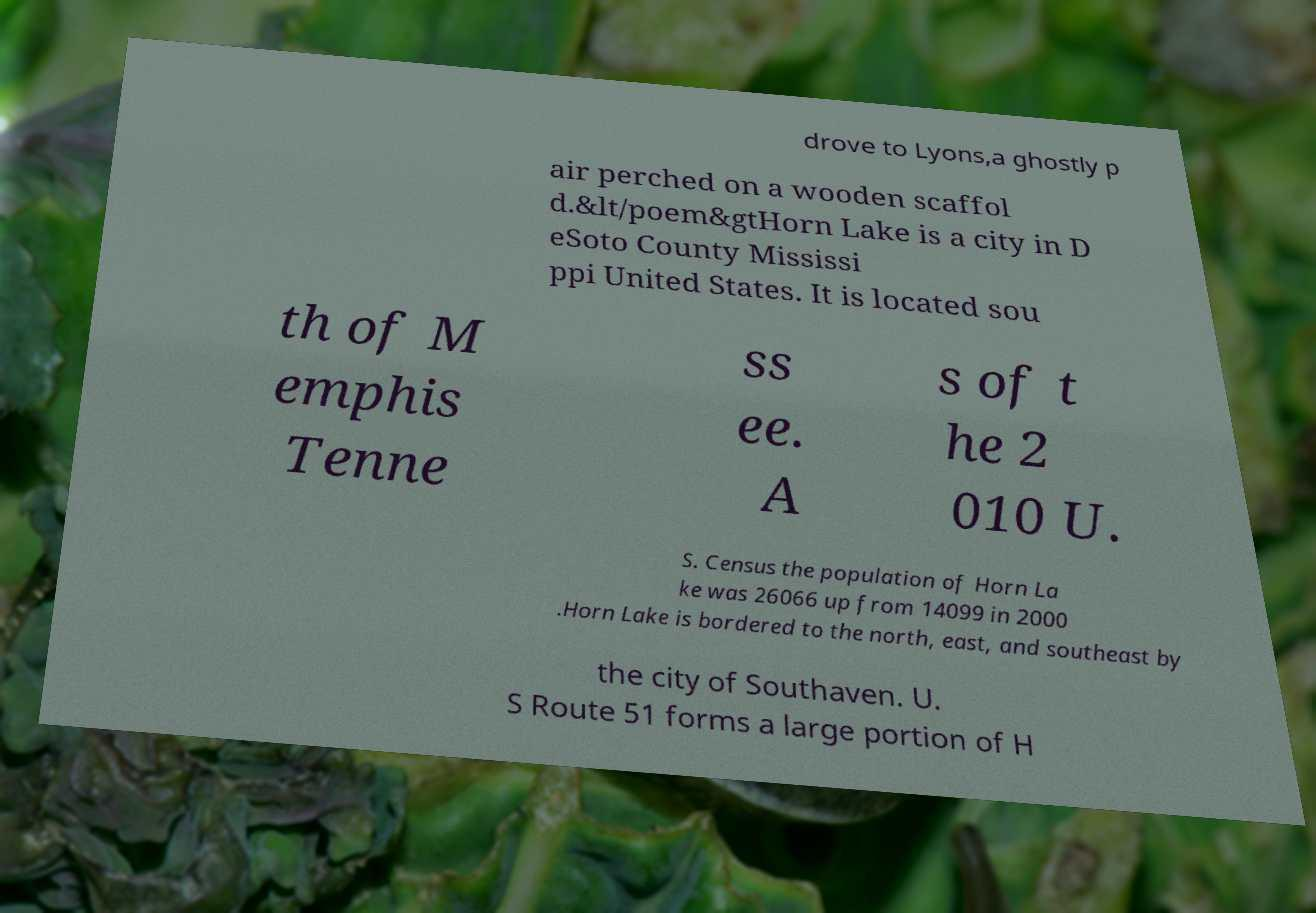I need the written content from this picture converted into text. Can you do that? drove to Lyons,a ghostly p air perched on a wooden scaffol d.&lt/poem&gtHorn Lake is a city in D eSoto County Mississi ppi United States. It is located sou th of M emphis Tenne ss ee. A s of t he 2 010 U. S. Census the population of Horn La ke was 26066 up from 14099 in 2000 .Horn Lake is bordered to the north, east, and southeast by the city of Southaven. U. S Route 51 forms a large portion of H 